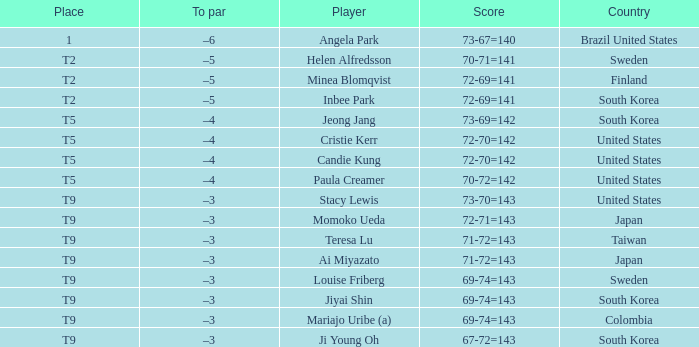What was Momoko Ueda's place? T9. 